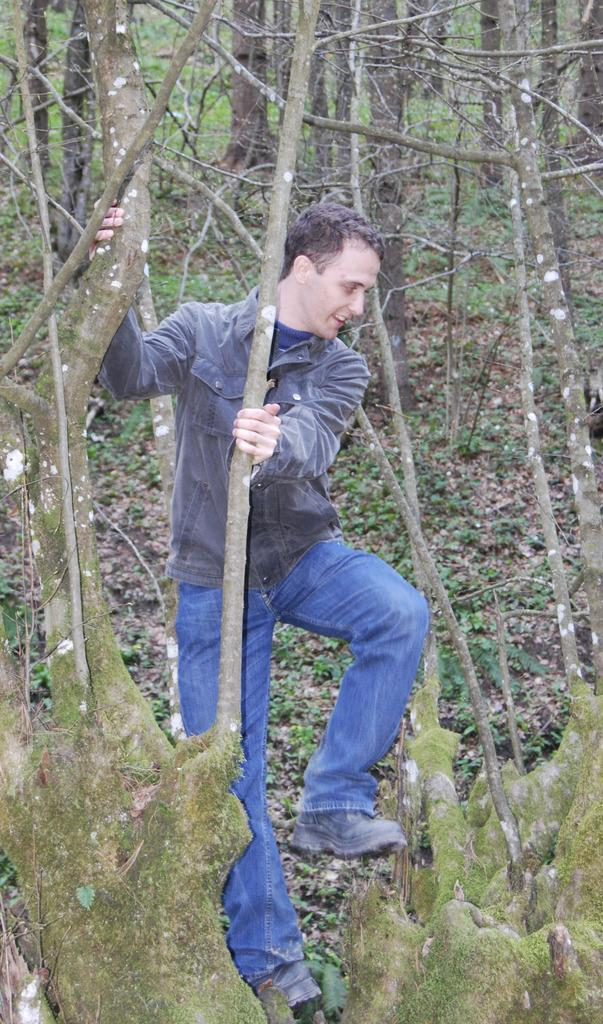What is the man in the image doing? The man is climbing a tree. What is the man wearing while climbing the tree? The man is wearing a coat. What is the man's facial expression in the image? The man is smiling. What can be seen in the background of the image? There are trees visible in the background. What holiday is the man celebrating in the image? There is no indication of a holiday in the image; the man is simply climbing a tree. 